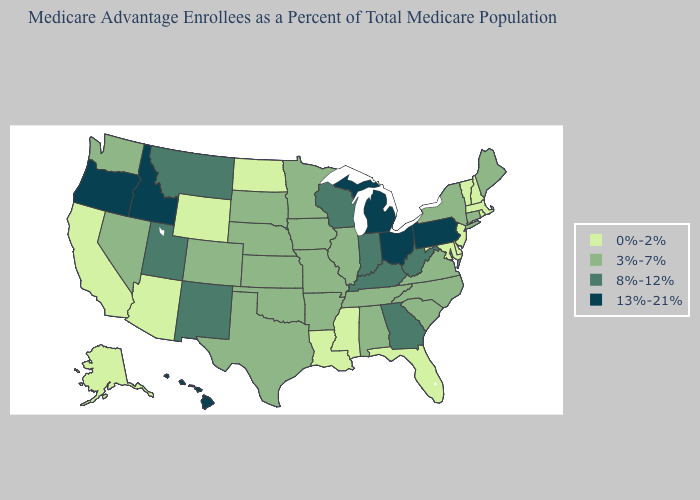Does Utah have a lower value than New York?
Keep it brief. No. Among the states that border Ohio , does West Virginia have the lowest value?
Write a very short answer. Yes. Name the states that have a value in the range 13%-21%?
Be succinct. Hawaii, Idaho, Michigan, Ohio, Oregon, Pennsylvania. Name the states that have a value in the range 13%-21%?
Be succinct. Hawaii, Idaho, Michigan, Ohio, Oregon, Pennsylvania. Name the states that have a value in the range 8%-12%?
Write a very short answer. Georgia, Indiana, Kentucky, Montana, New Mexico, Utah, Wisconsin, West Virginia. What is the lowest value in the South?
Keep it brief. 0%-2%. Does New York have the same value as Minnesota?
Short answer required. Yes. Does Ohio have the highest value in the MidWest?
Concise answer only. Yes. Name the states that have a value in the range 13%-21%?
Answer briefly. Hawaii, Idaho, Michigan, Ohio, Oregon, Pennsylvania. Does Massachusetts have the highest value in the USA?
Answer briefly. No. Name the states that have a value in the range 0%-2%?
Keep it brief. Alaska, Arizona, California, Delaware, Florida, Louisiana, Massachusetts, Maryland, Mississippi, North Dakota, New Hampshire, New Jersey, Rhode Island, Vermont, Wyoming. What is the highest value in the USA?
Short answer required. 13%-21%. Does Kentucky have the same value as West Virginia?
Be succinct. Yes. Among the states that border Ohio , does Pennsylvania have the highest value?
Answer briefly. Yes. What is the value of California?
Concise answer only. 0%-2%. 